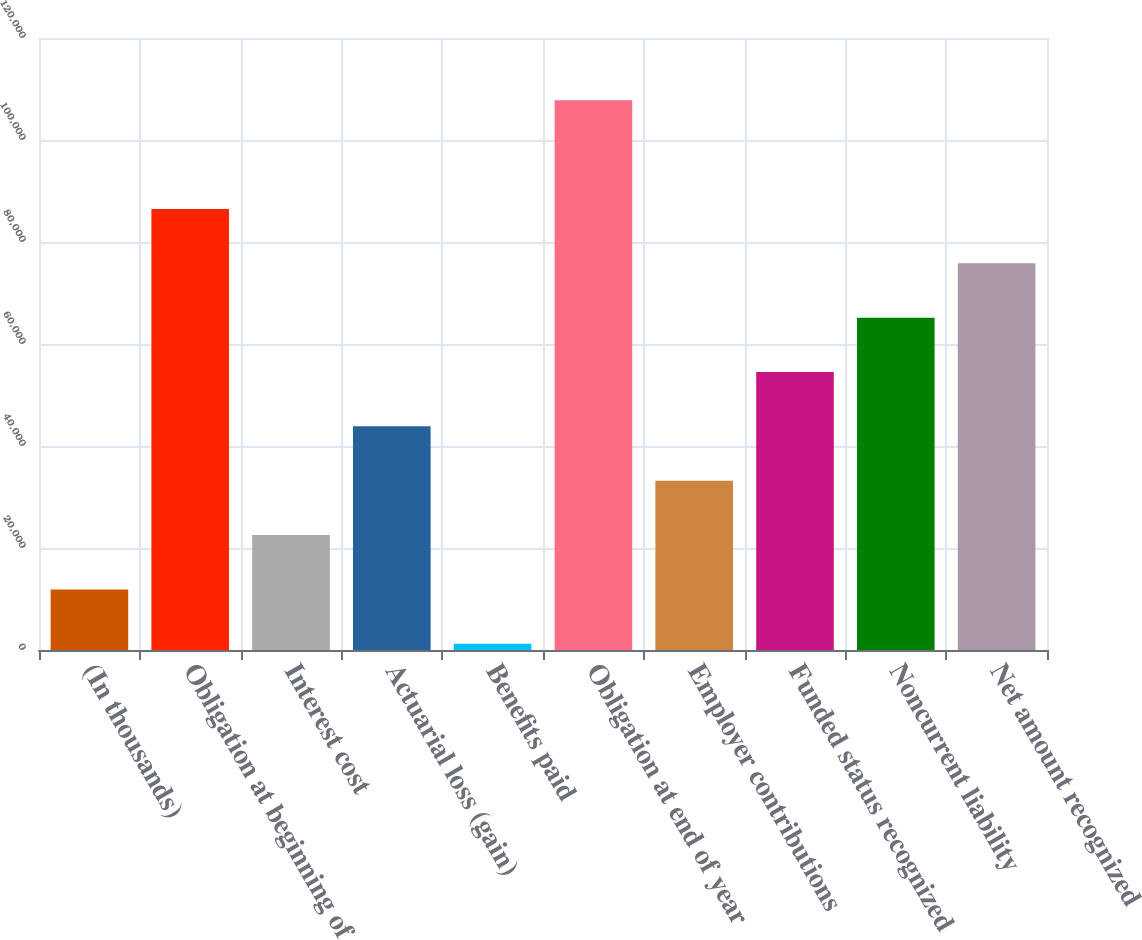<chart> <loc_0><loc_0><loc_500><loc_500><bar_chart><fcel>(In thousands)<fcel>Obligation at beginning of<fcel>Interest cost<fcel>Actuarial loss (gain)<fcel>Benefits paid<fcel>Obligation at end of year<fcel>Employer contributions<fcel>Funded status recognized<fcel>Noncurrent liability<fcel>Net amount recognized<nl><fcel>11872.8<fcel>86484.4<fcel>22531.6<fcel>43849.2<fcel>1214<fcel>107802<fcel>33190.4<fcel>54508<fcel>65166.8<fcel>75825.6<nl></chart> 